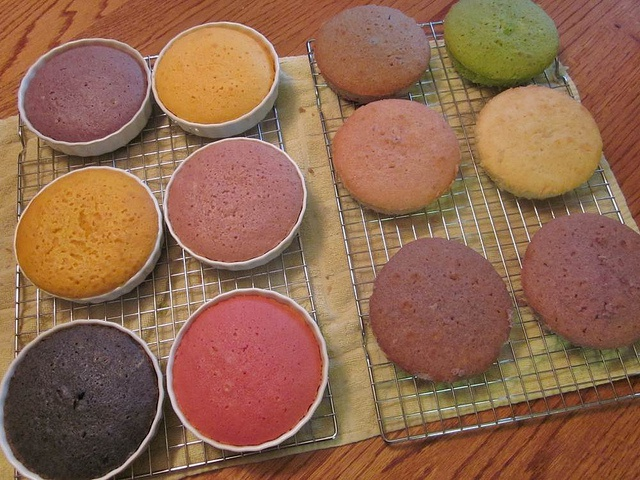Describe the objects in this image and their specific colors. I can see bowl in red, black, and gray tones, bowl in red, brown, and salmon tones, cake in red, black, and gray tones, cake in red, brown, and salmon tones, and cake in red and brown tones in this image. 